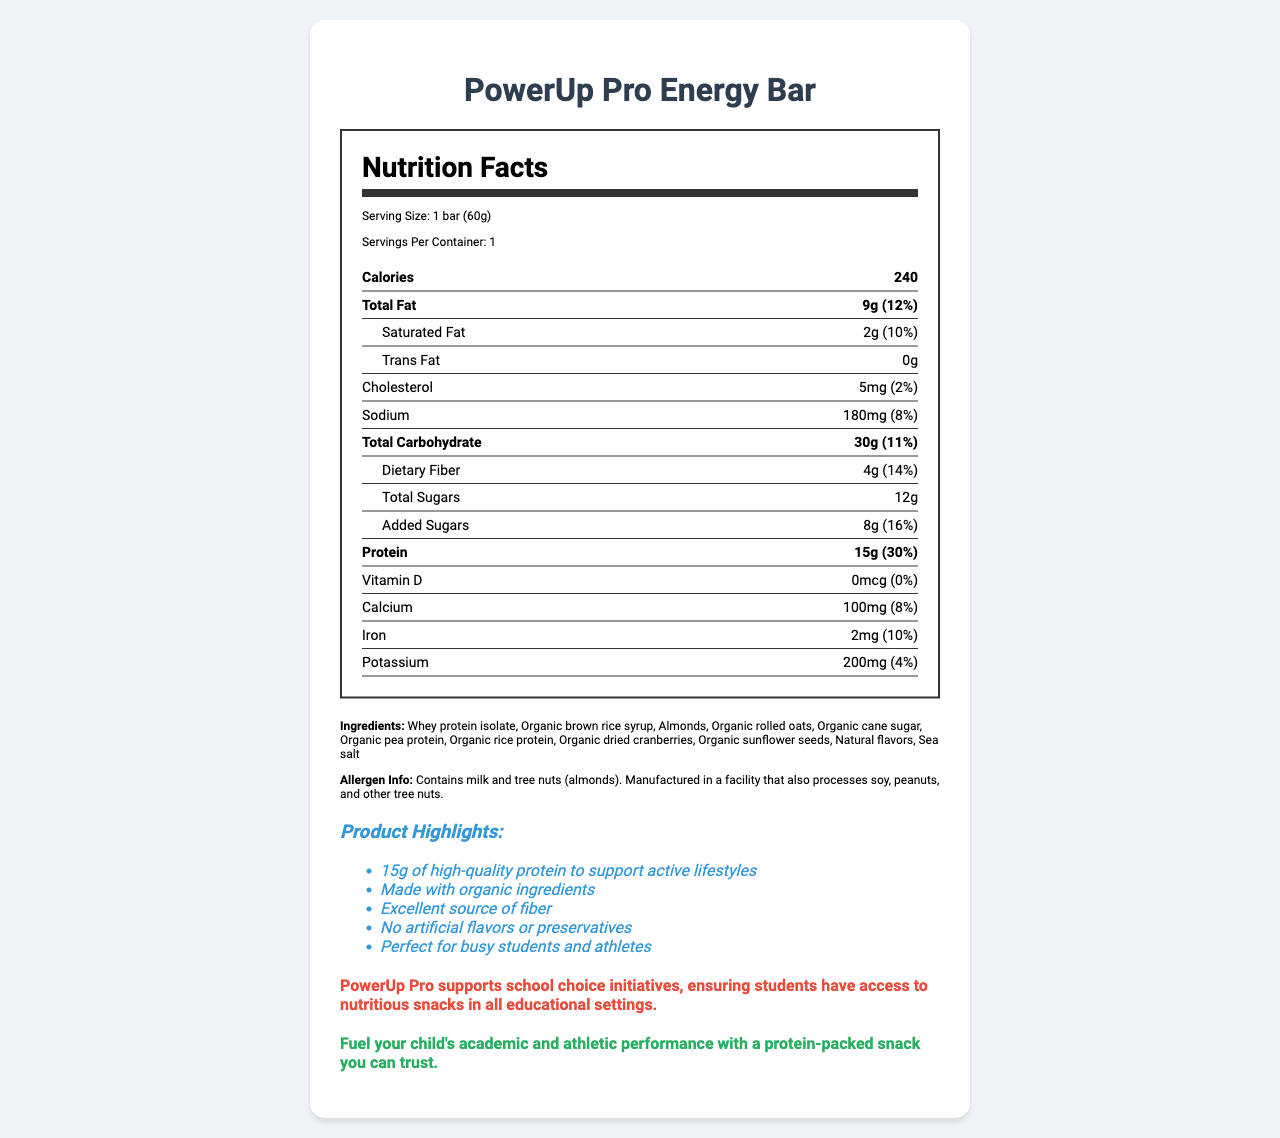who manufactures the PowerUp Pro Energy Bar? The document does not provide information about the manufacturer of the PowerUp Pro Energy Bar.
Answer: Cannot be determined What is the serving size of the PowerUp Pro Energy Bar? The serving size is directly stated as "1 bar (60g)" in the serving info section.
Answer: 1 bar (60g) How many grams of protein are in a serving of the PowerUp Pro Energy Bar? The protein content is listed as "15g" with a daily value percentage of 30%.
Answer: 15g What is the amount of added sugars in the PowerUp Pro Energy Bar? The document states that the amount of added sugars is 8g with a daily value percentage of 16%.
Answer: 8g Which allergen is mentioned in the allergen information section? A. Soy B. Milk C. Peanuts The allergen info states that the product contains milk and tree nuts (almonds).
Answer: B What is the total calorie count per serving of the PowerUp Pro Energy Bar? The calorie count per serving is clearly listed as 240 calories.
Answer: 240 calories What percentage of the daily value of calcium is provided by the PowerUp Pro Energy Bar? The document lists calcium content as 100mg, which is 8% of the daily value.
Answer: 8% Does the PowerUp Pro Energy Bar contain artificial flavors or preservatives? The marketing claims section states "No artificial flavors or preservatives."
Answer: No What is the main idea of the document? The document focuses on the nutritional values, ingredients, allergens, and marketing claims of the PowerUp Pro Energy Bar, emphasizing its benefits for students and active individuals.
Answer: The document provides detailed nutritional information about the PowerUp Pro Energy Bar, highlighting its high protein content, use of organic ingredients, absence of artificial flavors and preservatives, and support for school choice initiatives. How much sodium is in one serving of the PowerUp Pro Energy Bar? The sodium content in one serving is listed as 180mg, which is 8% of the daily value.
Answer: 180mg Describe one of the marketing claims made about the PowerUp Pro Energy Bar. One of the marketing claims is that the bar contains 15g of high-quality protein to support active lifestyles.
Answer: 15g of high-quality protein to support active lifestyles Which of the following is NOT listed as an ingredient in the PowerUp Pro Energy Bar? 1. Organic rolled oats 2. Sea salt 3. Artificial sweeteners The ingredients list does not include artificial sweeteners.
Answer: 3 How can this product benefit active students according to the marketing claims? The marketing claims emphasize high protein content, fiber, and absence of artificial flavors or preservatives, making it ideal for active students.
Answer: The bar contains 15g of protein, is an excellent source of fiber, and has no artificial flavors or preservatives, which make it a nutritious choice for students and athletes. What is the protein daily value percentage provided by the PowerUp Pro Energy Bar? The protein content daily value percentage is listed as 30%.
Answer: 30% Is there any vitamin D in the PowerUp Pro Energy Bar? The document states that the amount of vitamin D is 0mcg, with 0% of the daily value.
Answer: No 